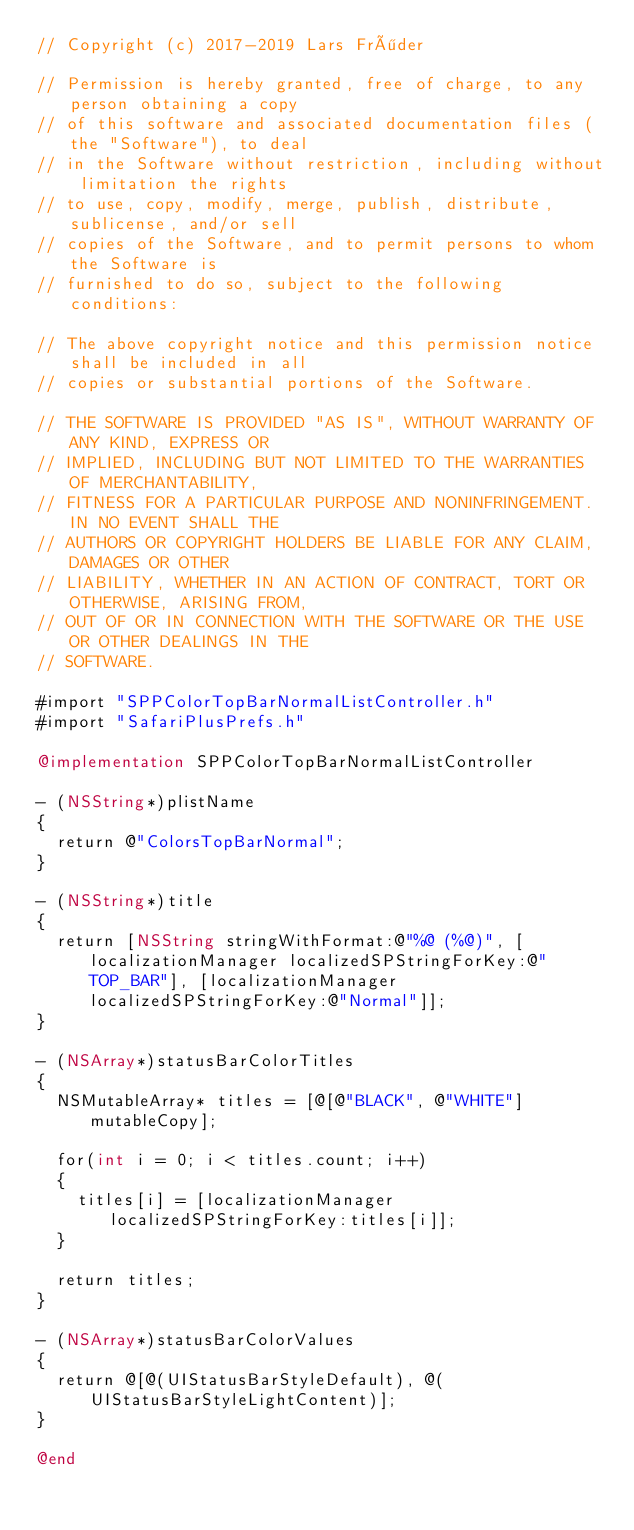Convert code to text. <code><loc_0><loc_0><loc_500><loc_500><_ObjectiveC_>// Copyright (c) 2017-2019 Lars Fröder

// Permission is hereby granted, free of charge, to any person obtaining a copy
// of this software and associated documentation files (the "Software"), to deal
// in the Software without restriction, including without limitation the rights
// to use, copy, modify, merge, publish, distribute, sublicense, and/or sell
// copies of the Software, and to permit persons to whom the Software is
// furnished to do so, subject to the following conditions:

// The above copyright notice and this permission notice shall be included in all
// copies or substantial portions of the Software.

// THE SOFTWARE IS PROVIDED "AS IS", WITHOUT WARRANTY OF ANY KIND, EXPRESS OR
// IMPLIED, INCLUDING BUT NOT LIMITED TO THE WARRANTIES OF MERCHANTABILITY,
// FITNESS FOR A PARTICULAR PURPOSE AND NONINFRINGEMENT. IN NO EVENT SHALL THE
// AUTHORS OR COPYRIGHT HOLDERS BE LIABLE FOR ANY CLAIM, DAMAGES OR OTHER
// LIABILITY, WHETHER IN AN ACTION OF CONTRACT, TORT OR OTHERWISE, ARISING FROM,
// OUT OF OR IN CONNECTION WITH THE SOFTWARE OR THE USE OR OTHER DEALINGS IN THE
// SOFTWARE.

#import "SPPColorTopBarNormalListController.h"
#import "SafariPlusPrefs.h"

@implementation SPPColorTopBarNormalListController

- (NSString*)plistName
{
	return @"ColorsTopBarNormal";
}

- (NSString*)title
{
	return [NSString stringWithFormat:@"%@ (%@)", [localizationManager localizedSPStringForKey:@"TOP_BAR"], [localizationManager localizedSPStringForKey:@"Normal"]];
}

- (NSArray*)statusBarColorTitles
{
	NSMutableArray* titles = [@[@"BLACK", @"WHITE"] mutableCopy];

	for(int i = 0; i < titles.count; i++)
	{
		titles[i] = [localizationManager localizedSPStringForKey:titles[i]];
	}

	return titles;
}

- (NSArray*)statusBarColorValues
{
	return @[@(UIStatusBarStyleDefault), @(UIStatusBarStyleLightContent)];
}

@end
</code> 